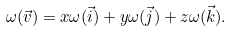<formula> <loc_0><loc_0><loc_500><loc_500>\omega ( { \vec { v } } ) = x \omega ( { \vec { i } } ) + y \omega ( { \vec { j } } ) + z \omega ( { \vec { k } } ) .</formula> 